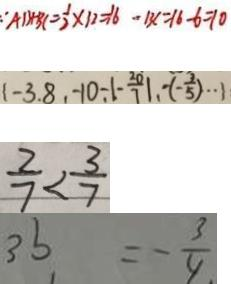Convert formula to latex. <formula><loc_0><loc_0><loc_500><loc_500>\because A B + B C = \frac { 1 } { 2 } \times 1 2 = 1 6 - B C = 1 6 - 6 = 1 0 
 1 - 3 . 8 , - 1 0 - \vert - \frac { 2 0 } { 7 } \vert , - ( - \frac { 3 } { 5 } ) \cdots 1 
 \frac { 2 } { 7 } < \frac { 3 } { 7 } 
 3 b = - \frac { 3 } { 4 } .</formula> 